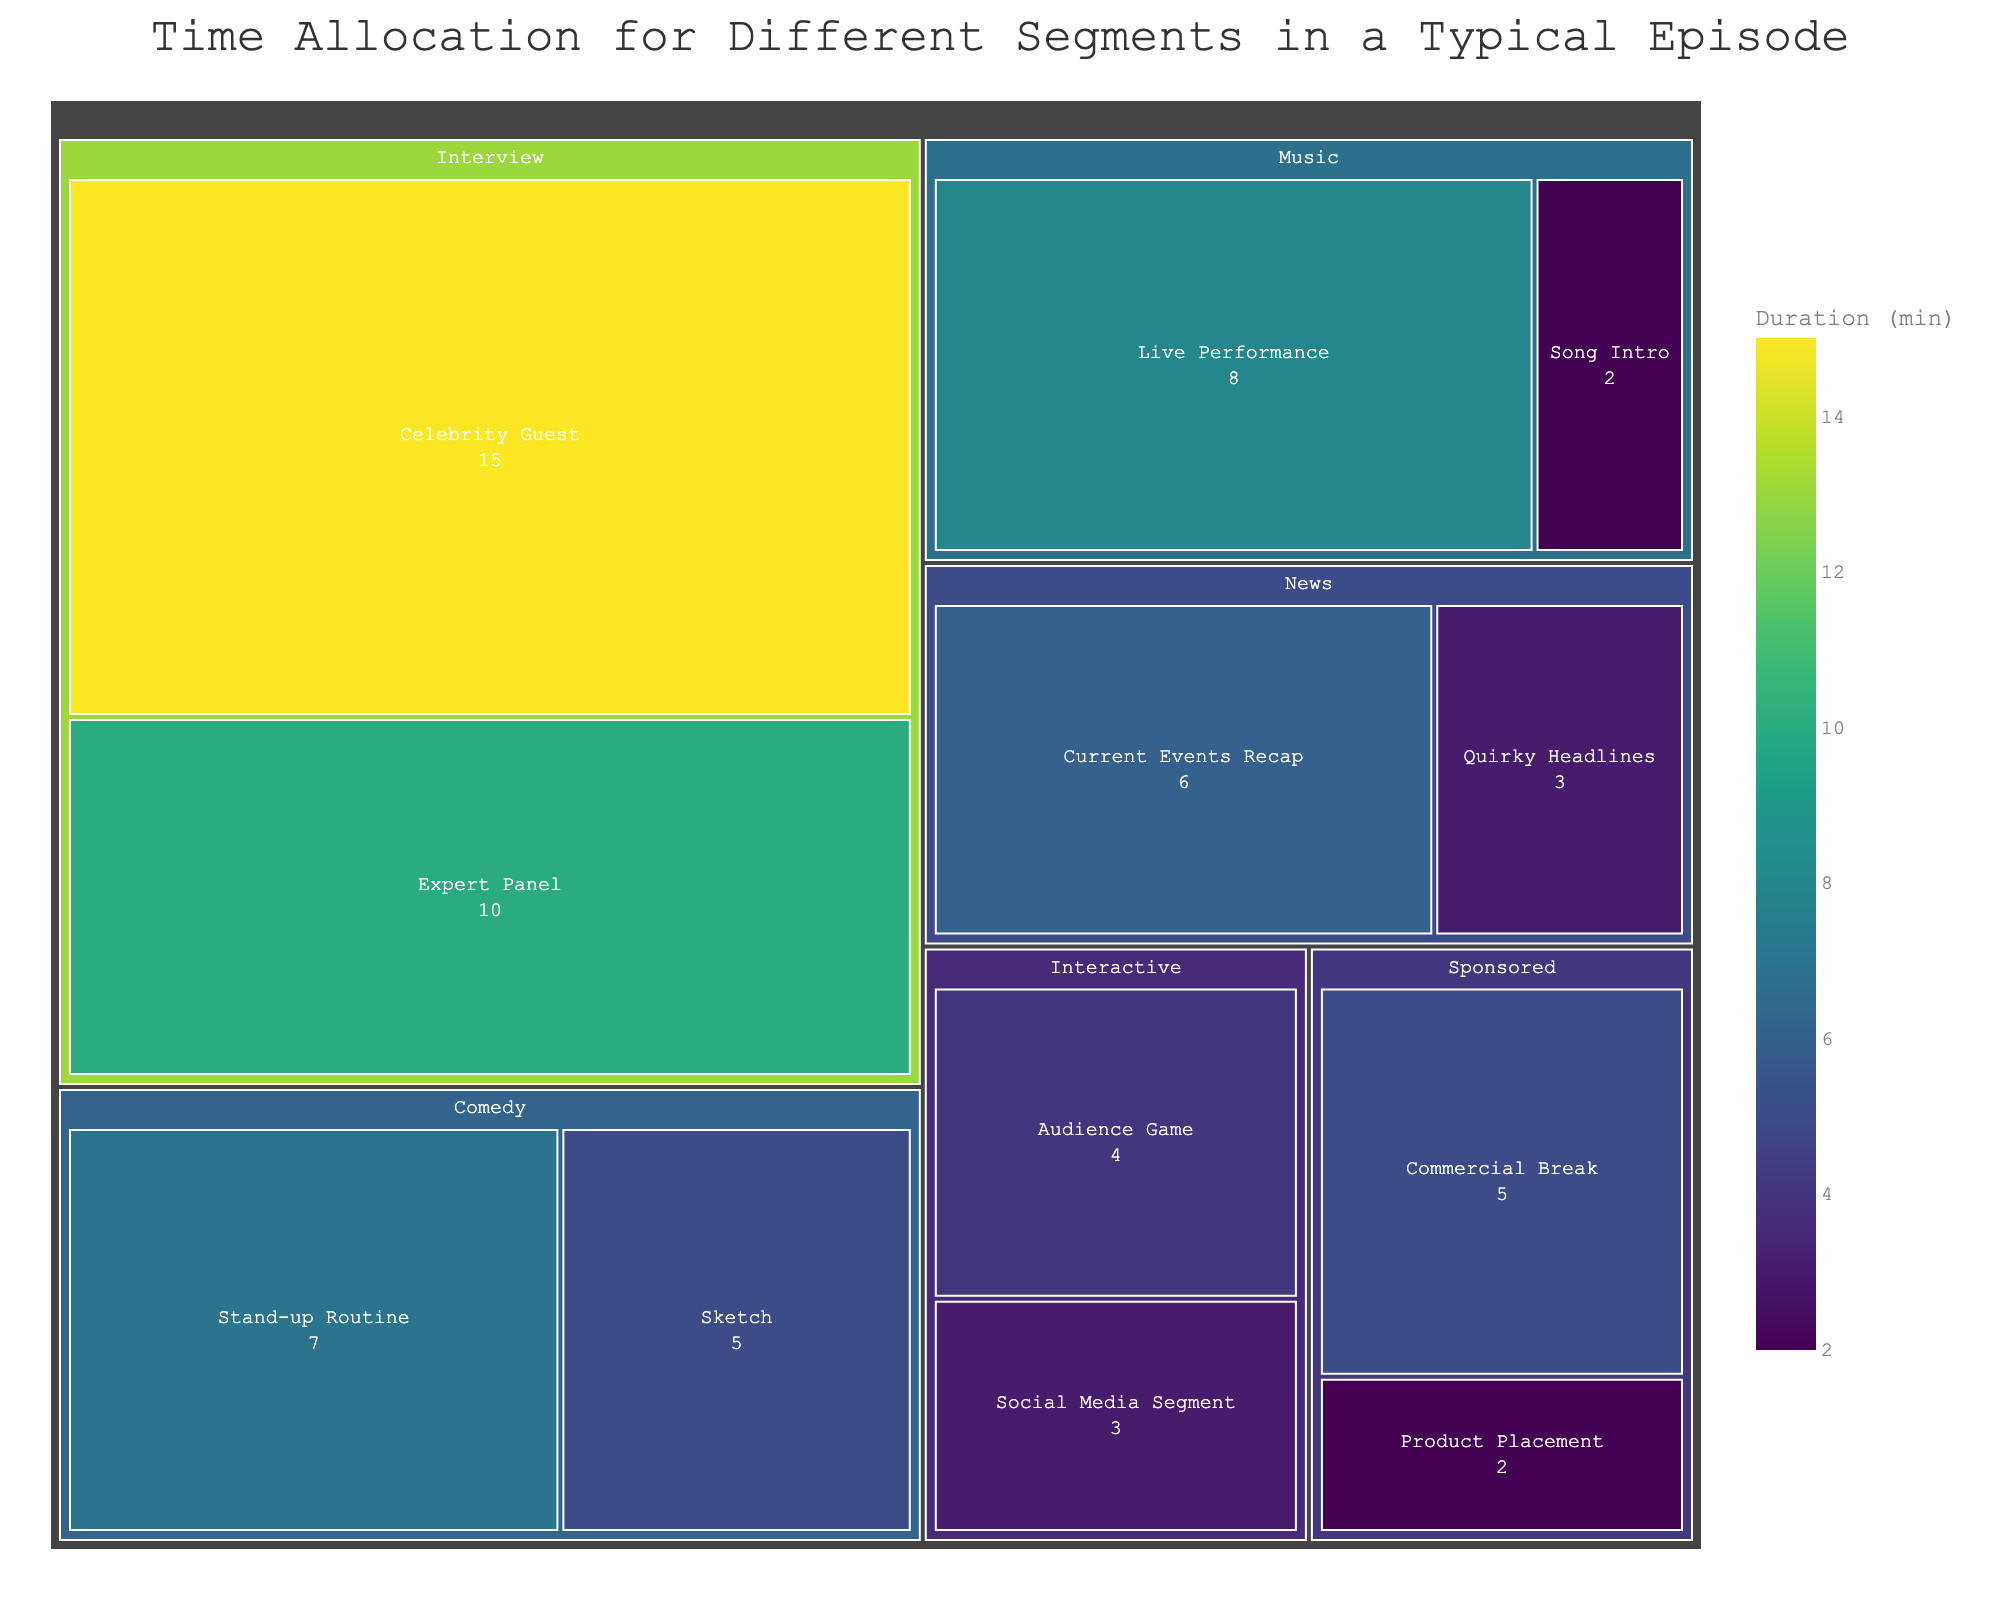What's the total duration allocated to the 'Comedy' category? To find the total duration for the 'Comedy' category, we need to sum the durations of all segments within it. There are two segments: 'Stand-up Routine' (7 minutes) and 'Sketch' (5 minutes). The sum is 7 + 5 = 12 minutes.
Answer: 12 minutes Which segment in the 'Interview' category has a longer duration? The 'Interview' category consists of two segments: 'Celebrity Guest' (15 minutes) and 'Expert Panel' (10 minutes). Comparing the two, 'Celebrity Guest' has a longer duration.
Answer: Celebrity Guest What's the shortest segment in the entire episode? By examining all the segments and their durations, the shortest segment is 'Song Intro' in the 'Music' category, which is 2 minutes long.
Answer: Song Intro How much longer is the 'Live Performance' segment compared to the 'Social Media Segment'? The 'Live Performance' segment duration is 8 minutes and the 'Social Media Segment' duration is 3 minutes. The difference between them is 8 - 3 = 5 minutes.
Answer: 5 minutes What is the combined duration of all segments related to music? The 'Music' category includes two segments: 'Live Performance' (8 minutes) and 'Song Intro' (2 minutes). The combined duration is 8 + 2 = 10 minutes.
Answer: 10 minutes Which category occupies the largest portion of the treemap? By comparing the categories based on their total durations, the 'Interview' category has the longest total duration with segments 'Celebrity Guest' (15 minutes) and 'Expert Panel' (10 minutes), adding up to 25 minutes.
Answer: Interview How does the duration of 'Current Events Recap' compare to 'Quirky Headlines'? The 'Current Events Recap' segment has a duration of 6 minutes, whereas 'Quirky Headlines' has 3 minutes. 'Current Events Recap' is twice as long as 'Quirky Headlines'.
Answer: Twice as long What's the second highest total duration category? To find the second highest duration, sum the durations within each category, and compare. 'Interview' has the highest with 25 minutes, but the second highest is 'Comedy' with a total of 12 minutes (7 minutes for 'Stand-up Routine' + 5 minutes for 'Sketch').
Answer: Comedy Add up the total durations for Interactive and Sponsored categories. The 'Interactive' category has 'Audience Game' (4 minutes) and 'Social Media Segment' (3 minutes), totaling 4 + 3 = 7 minutes. The 'Sponsored' category has 'Product Placement' (2 minutes) and 'Commercial Break' (5 minutes), totaling 2 + 5 = 7 minutes. Summing them together, we get 7 + 7 = 14 minutes.
Answer: 14 minutes 